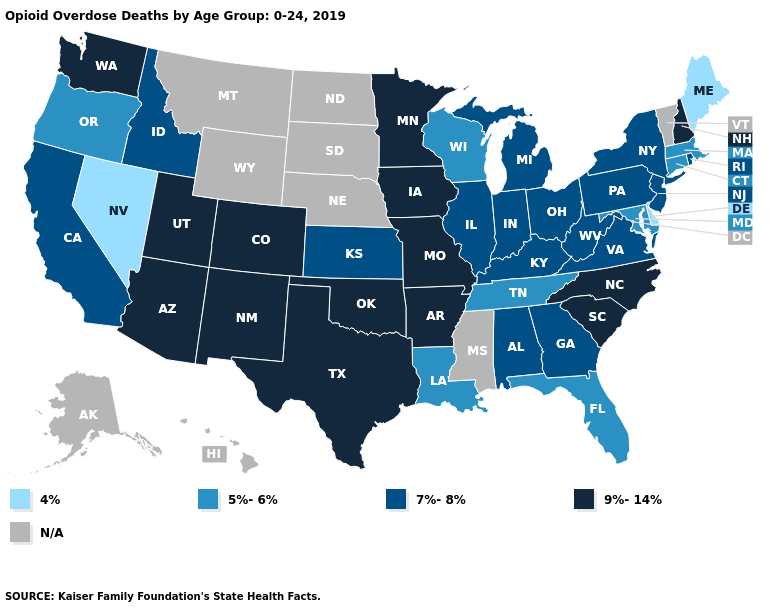Is the legend a continuous bar?
Keep it brief. No. Does the first symbol in the legend represent the smallest category?
Give a very brief answer. Yes. Among the states that border New Mexico , which have the lowest value?
Concise answer only. Arizona, Colorado, Oklahoma, Texas, Utah. Which states hav the highest value in the West?
Give a very brief answer. Arizona, Colorado, New Mexico, Utah, Washington. What is the value of New Hampshire?
Keep it brief. 9%-14%. Name the states that have a value in the range 5%-6%?
Keep it brief. Connecticut, Florida, Louisiana, Maryland, Massachusetts, Oregon, Tennessee, Wisconsin. Is the legend a continuous bar?
Quick response, please. No. Name the states that have a value in the range 9%-14%?
Answer briefly. Arizona, Arkansas, Colorado, Iowa, Minnesota, Missouri, New Hampshire, New Mexico, North Carolina, Oklahoma, South Carolina, Texas, Utah, Washington. What is the value of California?
Concise answer only. 7%-8%. Among the states that border Idaho , which have the highest value?
Keep it brief. Utah, Washington. Does Maine have the lowest value in the USA?
Be succinct. Yes. What is the value of Florida?
Give a very brief answer. 5%-6%. Is the legend a continuous bar?
Quick response, please. No. Name the states that have a value in the range 4%?
Keep it brief. Delaware, Maine, Nevada. 